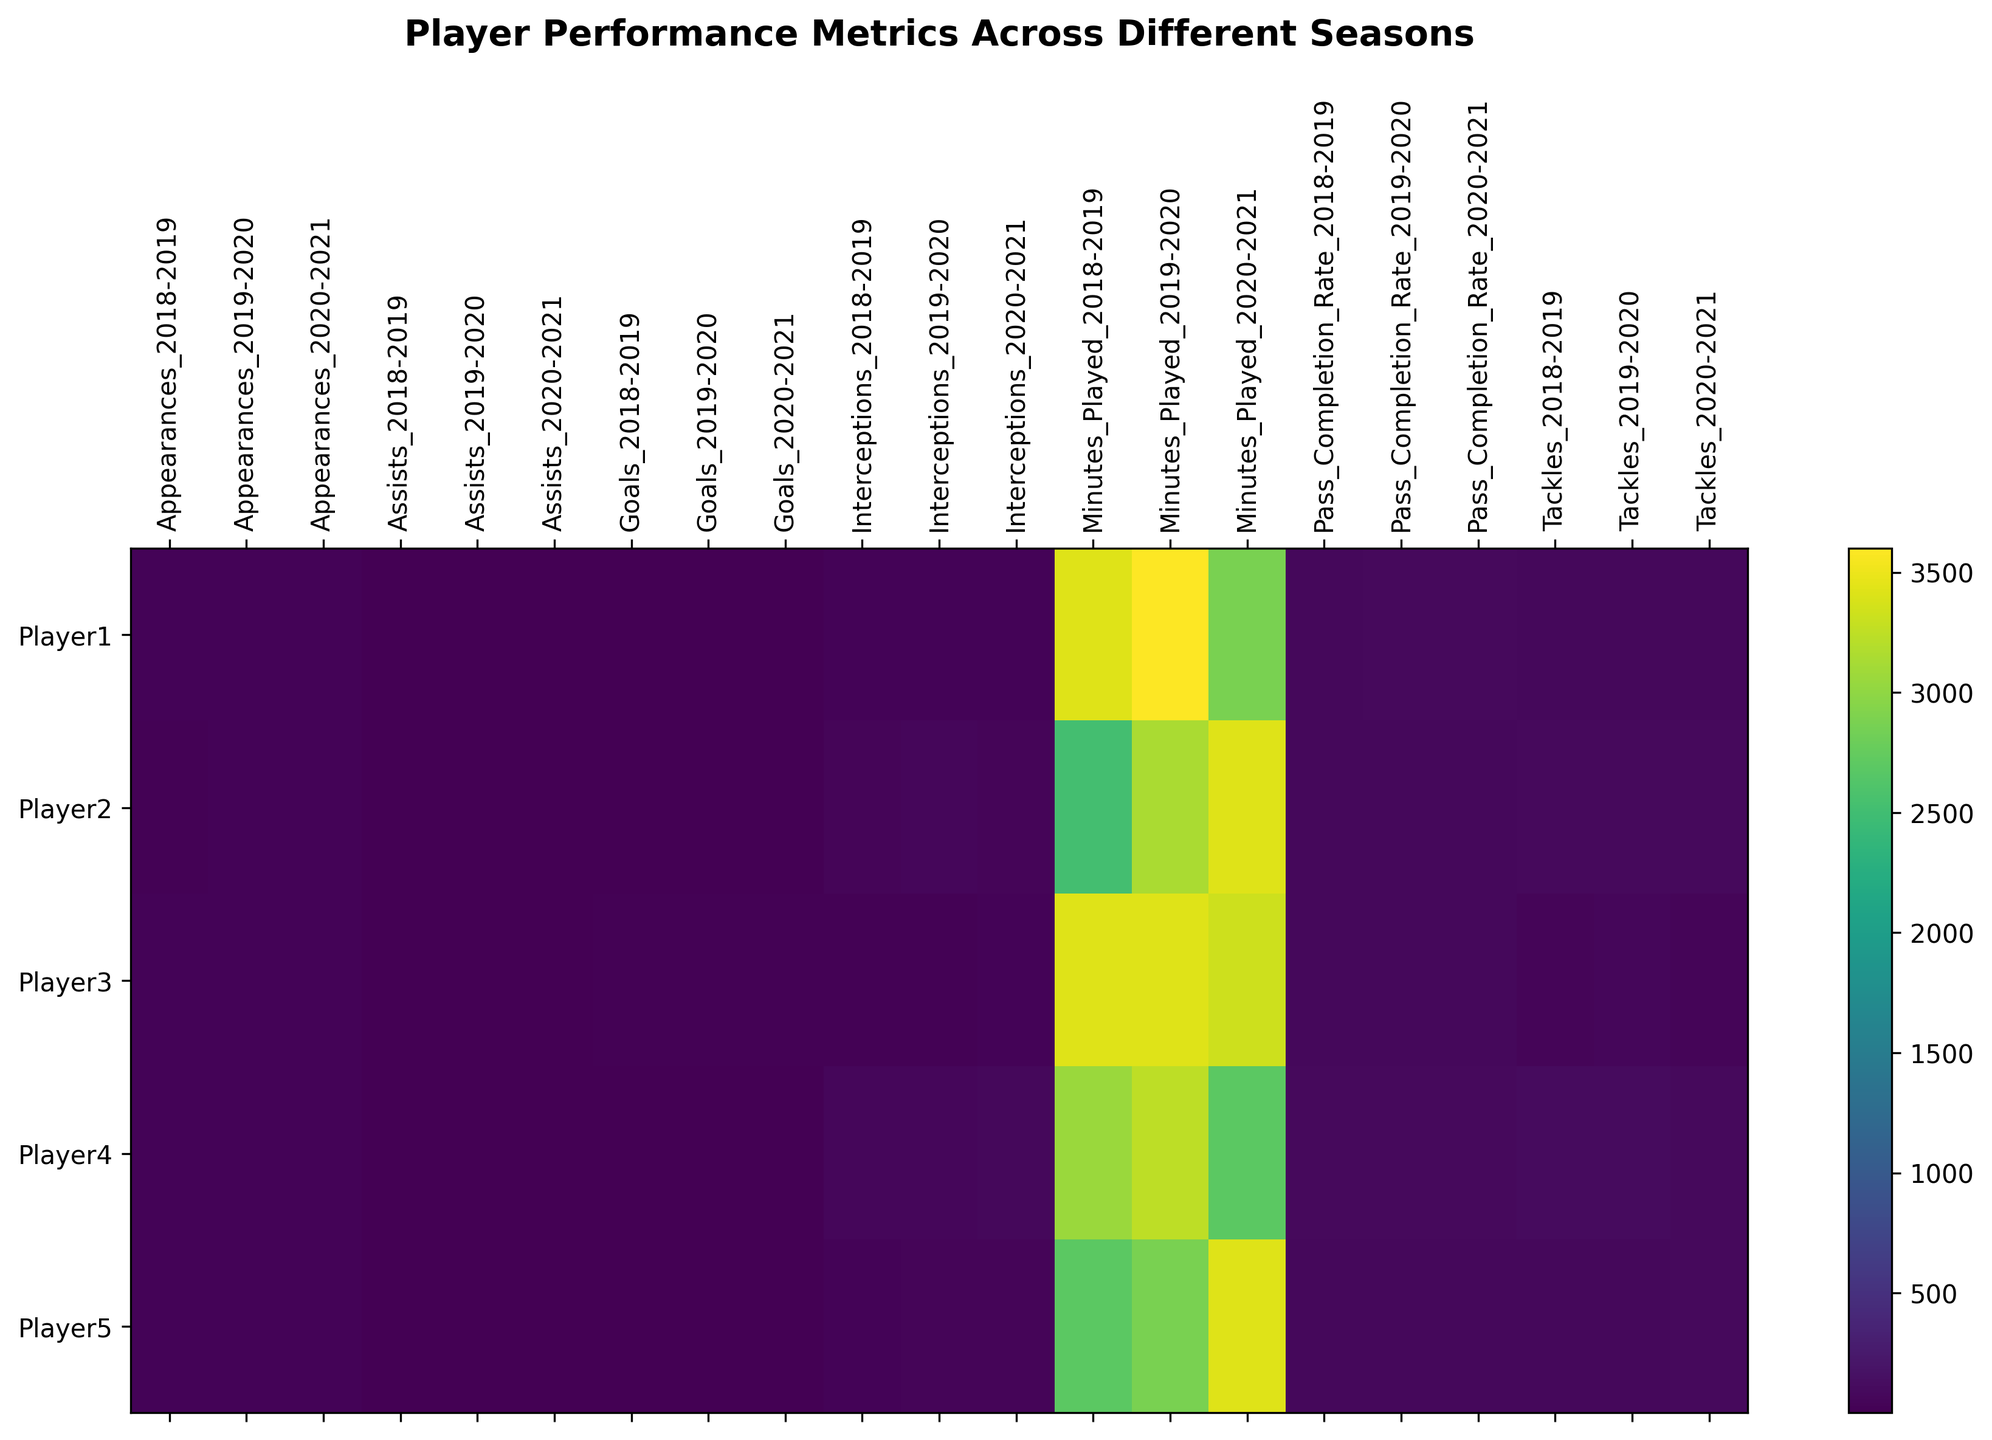What's the player with the highest number of goals in the 2019-2020 season? Look at the Goals column for the 2019-2020 season and identify the player with the highest value. The player with the highest number of goals is Player3 with 25 goals.
Answer: Player3 Which player has the lowest Pass Completion Rate across all seasons? Compare the Pass Completion Rate values across all rows and seasons to identify the lowest value. The lowest rate is 76%, which belongs to Player5 during the 2018-2019 season.
Answer: Player5 Who had more assists in the 2020-2021 season, Player1 or Player3? Compare the Assists values for Player1 and Player3 in the 2020-2021 season. Player1 has 7 assists while Player3 has 13 assists; thus, Player3 has more assists.
Answer: Player3 In the 2018-2019 season, which player made the most tackles, and how many tackles did they make? Look at the Tackles column for the 2018-2019 season and identify the player with the highest value. Player4 made the most tackles with 105 tackles.
Answer: Player4, 105 Which season did Player2 have the highest number of minutes played, and how many minutes were played? Compare the Minutes Played for Player2 across all seasons and identify the highest value. Player2 has the highest minutes played in the 2020-2021 season with 3420 minutes.
Answer: 2020-2021, 3420 What's the difference in interceptions made by Player4 between the 2018-2019 and 2019-2020 seasons? Subtract the value of interceptions made in the 2018-2019 season from those made in the 2019-2020 season for Player4. Player4 had 70 interceptions in 2018-2019 and 65 in 2019-2020, resulting in a difference of 5 interceptions.
Answer: 5 Which player showed the greatest improvement in goals scored from the 2018-2019 season to the 2019-2020 season? Compare the increase in goals scored by each player from the 2018-2019 season to the 2019-2020 season. Player3 had an increase of 5 goals, Player5 increased by 2 goals, Player1 increased by 3 goals, and Player2 increased by 2 goals. Thus, Player3 showed the greatest improvement.
Answer: Player3 What is the average pass completion rate for Player1 across all seasons? Add the Pass Completion Rates for Player1 across all three seasons and divide by the number of seasons. The rates are 85, 87, and 90, which sums to 262. Dividing 262 by 3 gives an average of approximately 87.33.
Answer: 87.33 Which player had the least appearances in the 2020-2021 season, and how many appearances did they make? Look at the Appearances column for all players in the 2020-2021 season and identify the lowest value. The least appearances in the 2020-2021 season were made by Player4 with 30 appearances.
Answer: Player4, 30 Which metric shows the largest change for Player2 from the 2019-2020 to the 2020-2021 season? Calculate the change for each metric (Goals, Assists, Appearances, Pass Completion Rate, Minutes Played, Tackles, Interceptions) for Player2 between the 2019-2020 and 2020-2021 seasons. Goals increased by 2, Assists increased by 3, Appearances increased by 3, Pass Completion Rate increased by 2, Minutes Played increased by 270, Tackles decreased by 7, and Interceptions decreased by 5. The largest change is in Minutes Played, which increased by 270.
Answer: Minutes Played 